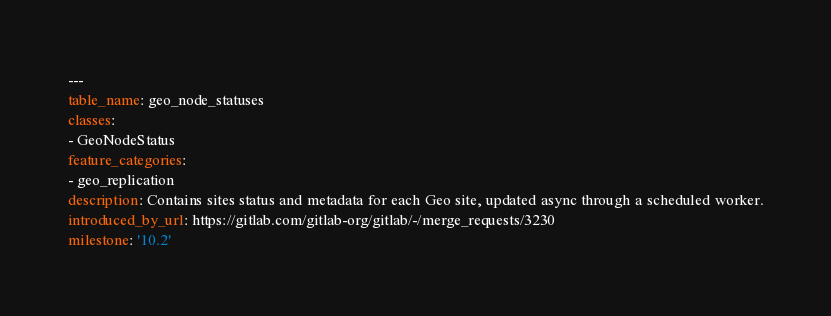<code> <loc_0><loc_0><loc_500><loc_500><_YAML_>---
table_name: geo_node_statuses
classes:
- GeoNodeStatus
feature_categories:
- geo_replication
description: Contains sites status and metadata for each Geo site, updated async through a scheduled worker.
introduced_by_url: https://gitlab.com/gitlab-org/gitlab/-/merge_requests/3230
milestone: '10.2'
</code> 